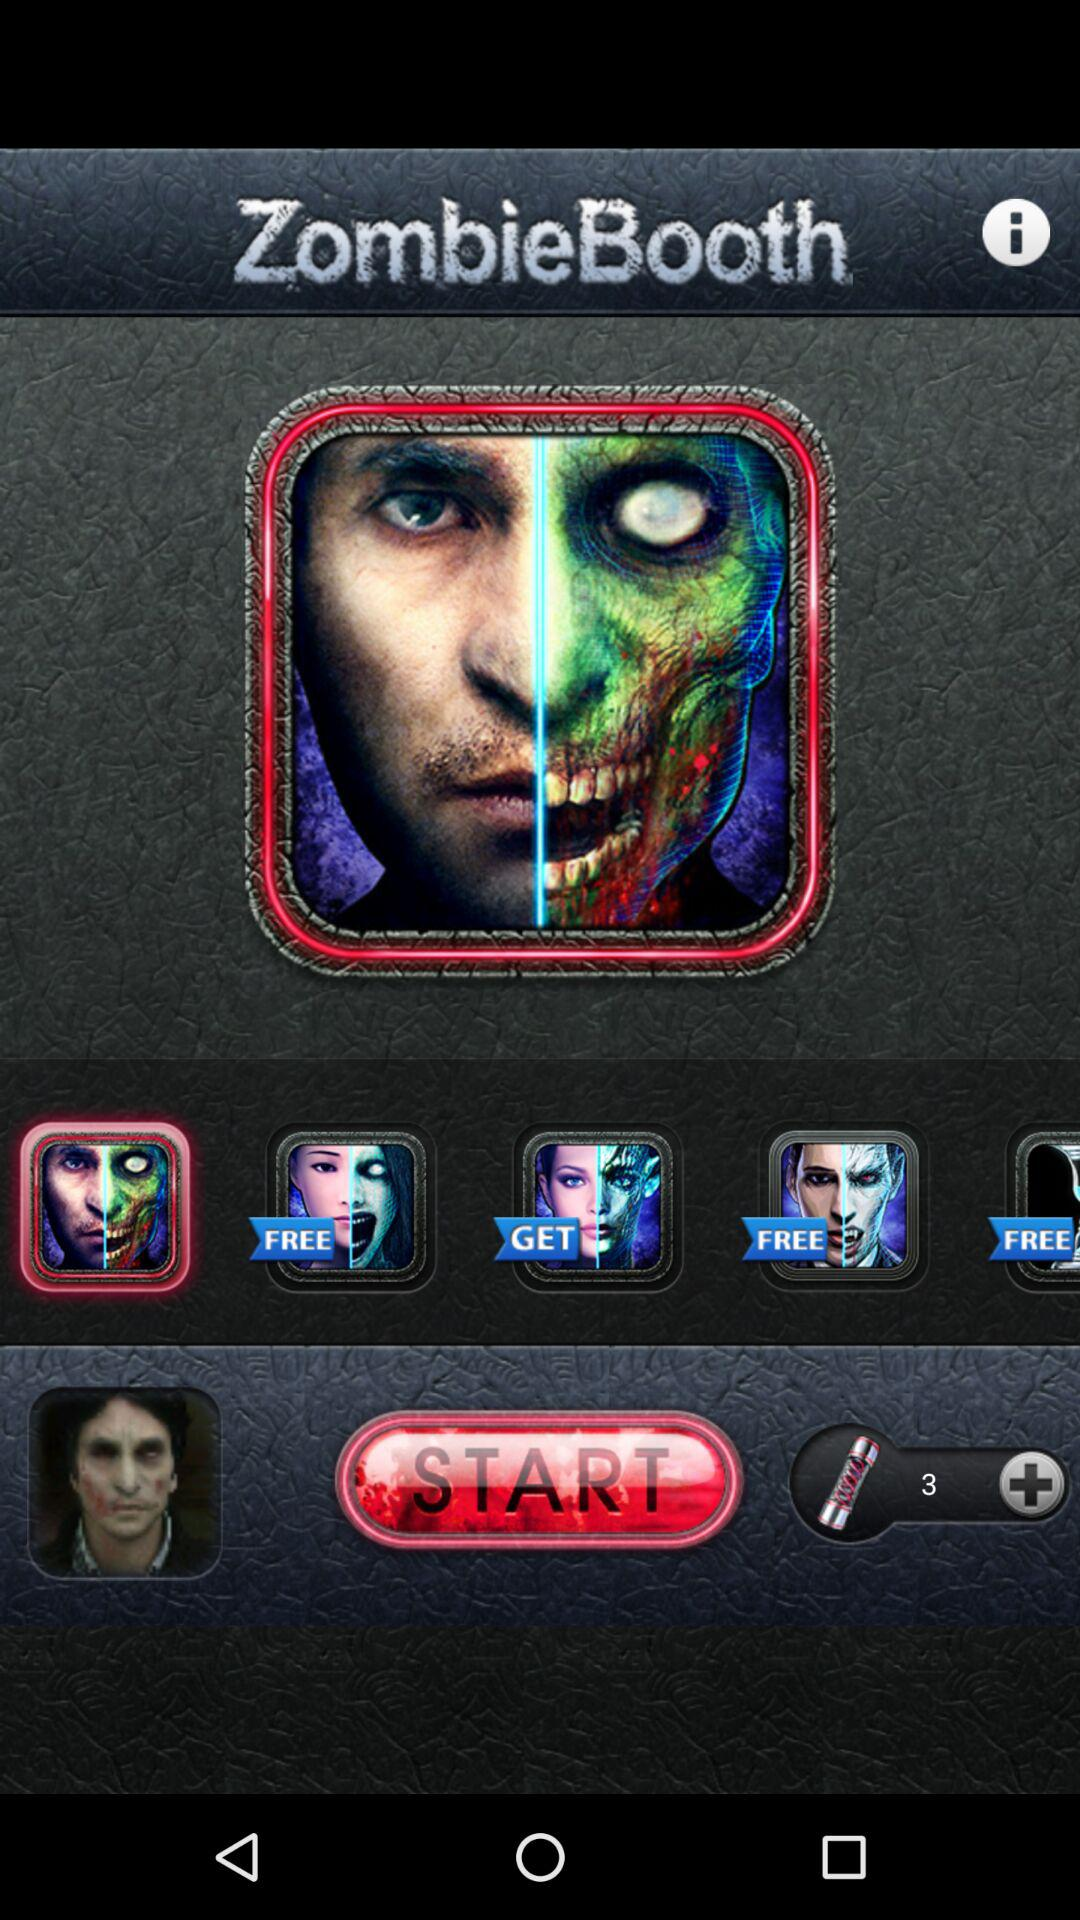What is the application name? The application name is "ZombieBooth". 